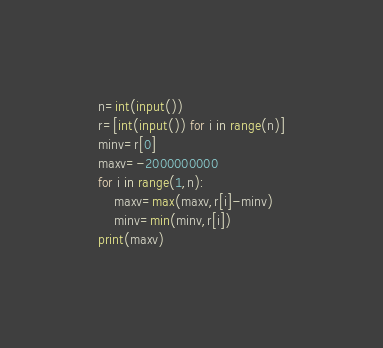<code> <loc_0><loc_0><loc_500><loc_500><_Python_>n=int(input())
r=[int(input()) for i in range(n)]
minv=r[0]
maxv=-2000000000
for i in range(1,n):
    maxv=max(maxv,r[i]-minv)
    minv=min(minv,r[i])
print(maxv)
</code> 